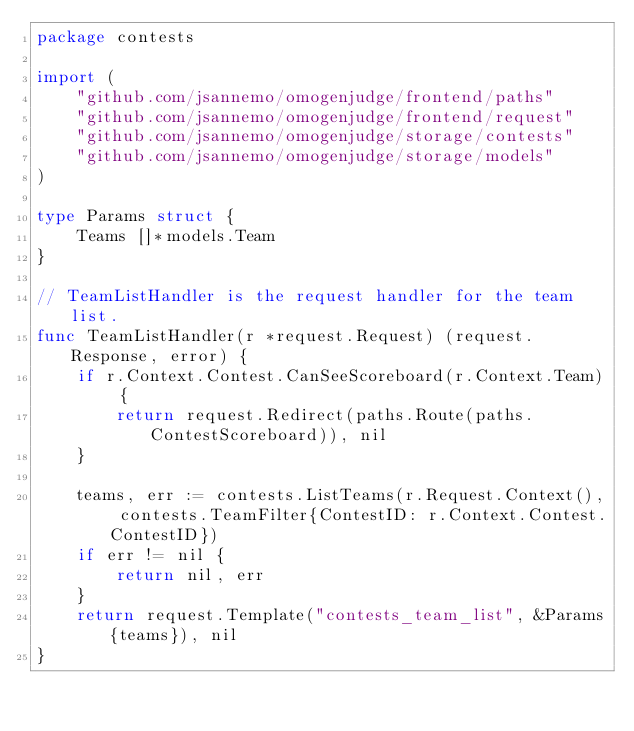Convert code to text. <code><loc_0><loc_0><loc_500><loc_500><_Go_>package contests

import (
	"github.com/jsannemo/omogenjudge/frontend/paths"
	"github.com/jsannemo/omogenjudge/frontend/request"
	"github.com/jsannemo/omogenjudge/storage/contests"
	"github.com/jsannemo/omogenjudge/storage/models"
)

type Params struct {
	Teams []*models.Team
}

// TeamListHandler is the request handler for the team list.
func TeamListHandler(r *request.Request) (request.Response, error) {
	if r.Context.Contest.CanSeeScoreboard(r.Context.Team) {
		return request.Redirect(paths.Route(paths.ContestScoreboard)), nil
	}

	teams, err := contests.ListTeams(r.Request.Context(), contests.TeamFilter{ContestID: r.Context.Contest.ContestID})
	if err != nil {
		return nil, err
	}
	return request.Template("contests_team_list", &Params{teams}), nil
}
</code> 